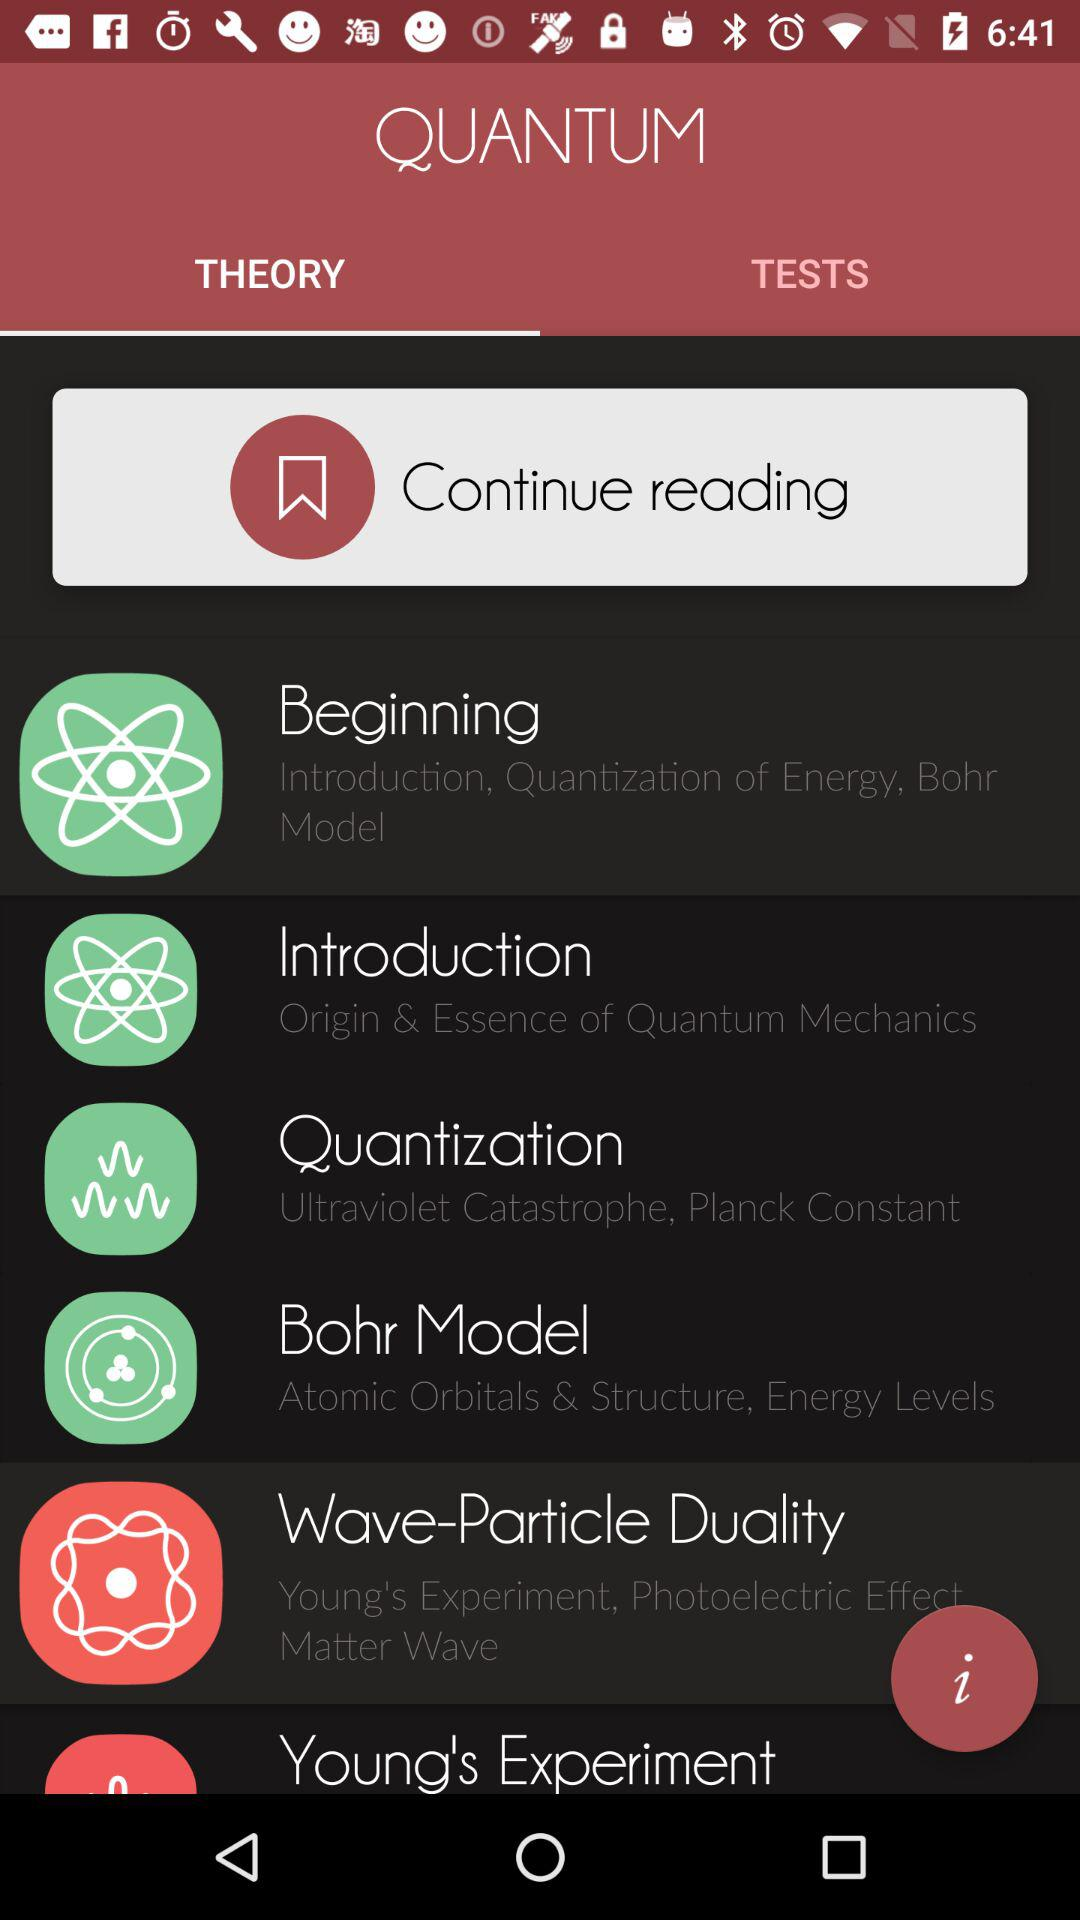Which tab is selected? The selected tab is "THEORY". 